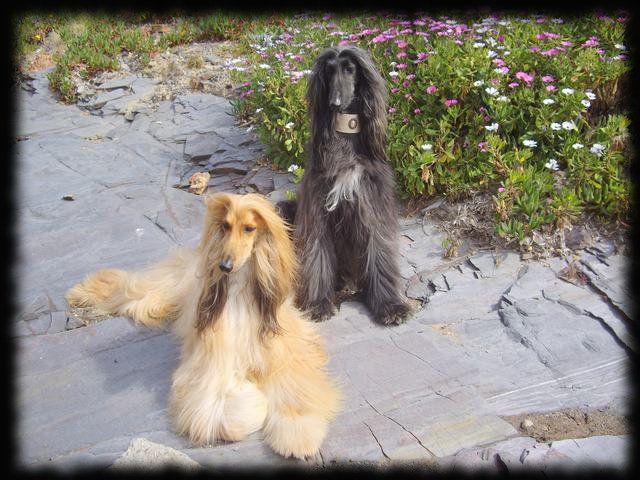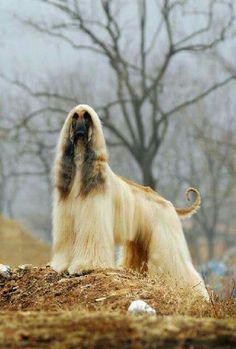The first image is the image on the left, the second image is the image on the right. Given the left and right images, does the statement "A total of three afghan hounds are shown, including one hound that stands alone in an image and gazes toward the camera, and a reclining hound that is on the left of another dog in the other image." hold true? Answer yes or no. Yes. The first image is the image on the left, the second image is the image on the right. For the images shown, is this caption "There are 3 dogs." true? Answer yes or no. Yes. 